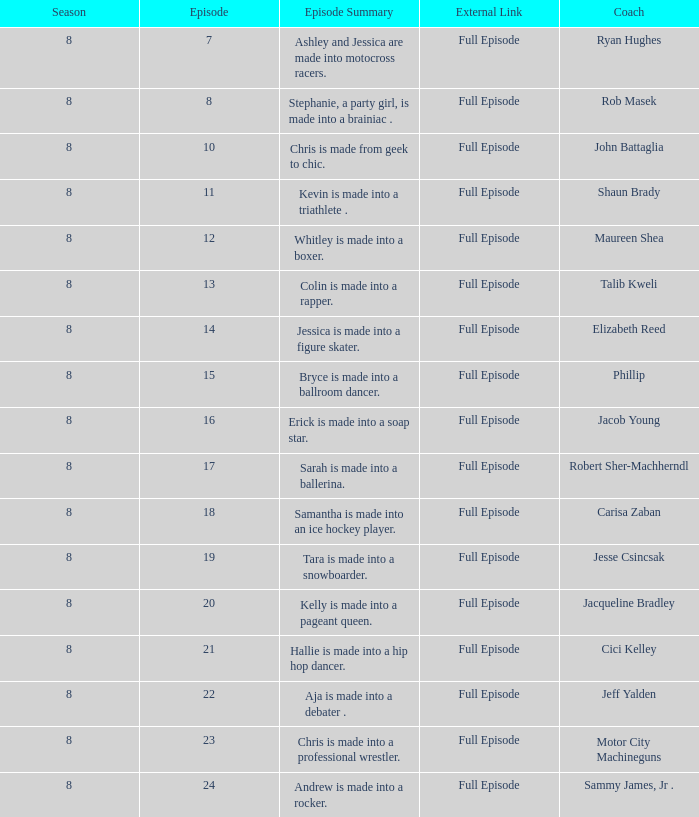What coach premiered February 16, 2008 later than episode 21.0? Jeff Yalden. 